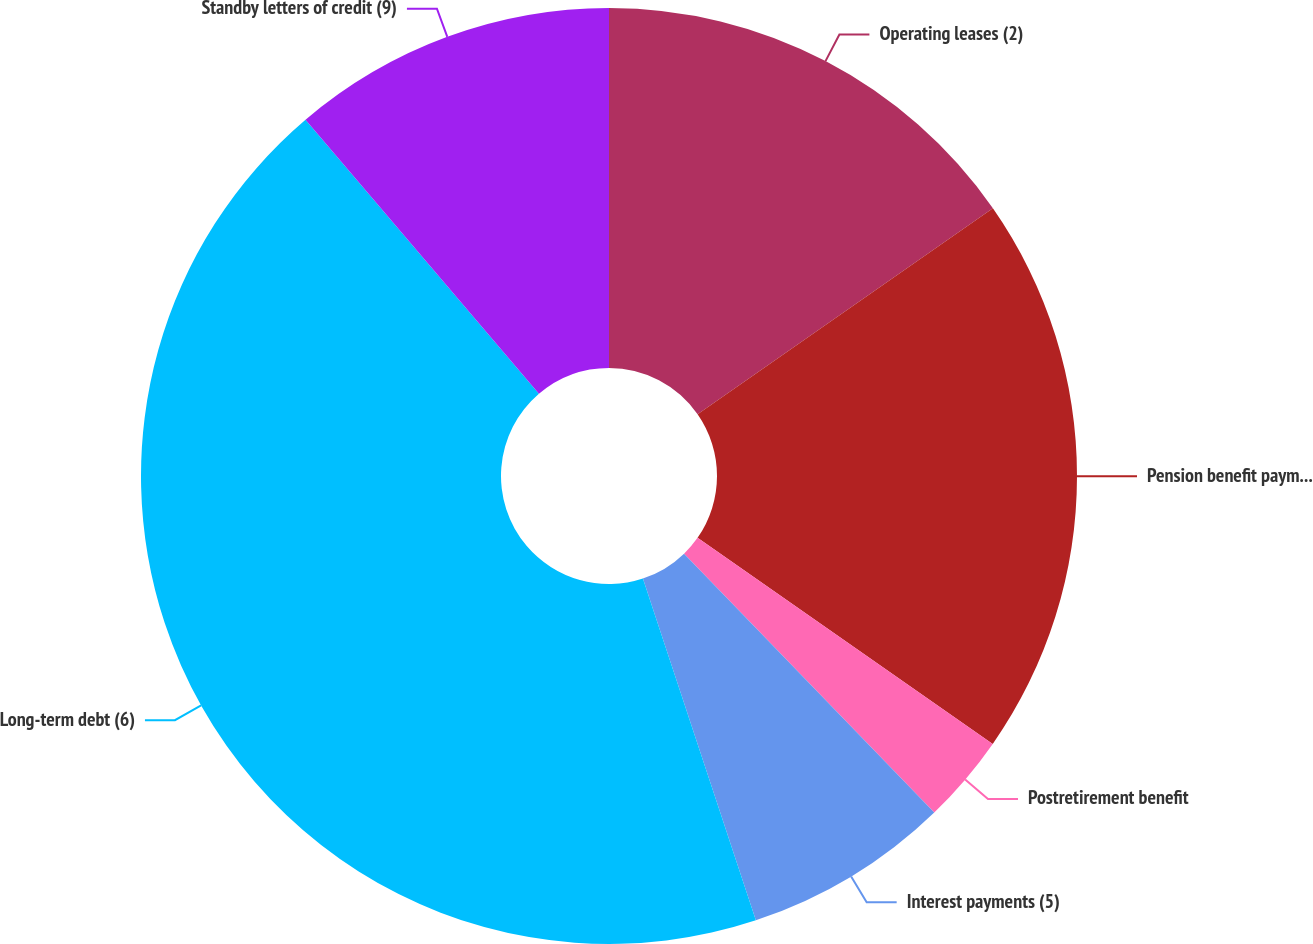Convert chart to OTSL. <chart><loc_0><loc_0><loc_500><loc_500><pie_chart><fcel>Operating leases (2)<fcel>Pension benefit payments (3)<fcel>Postretirement benefit<fcel>Interest payments (5)<fcel>Long-term debt (6)<fcel>Standby letters of credit (9)<nl><fcel>15.31%<fcel>19.39%<fcel>3.07%<fcel>7.15%<fcel>43.85%<fcel>11.23%<nl></chart> 